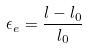<formula> <loc_0><loc_0><loc_500><loc_500>\epsilon _ { e } = \frac { l - l _ { 0 } } { l _ { 0 } }</formula> 